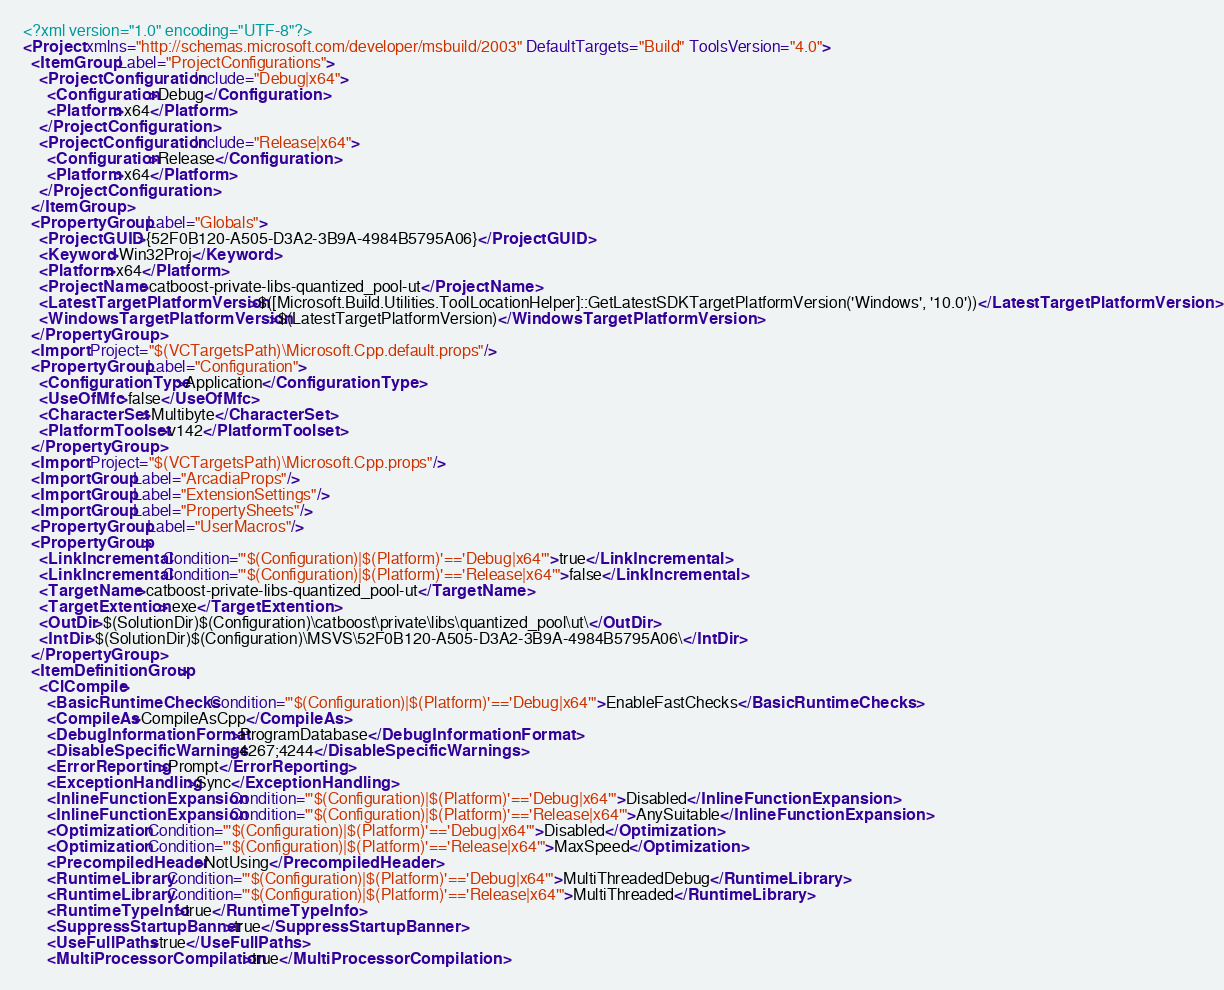Convert code to text. <code><loc_0><loc_0><loc_500><loc_500><_XML_><?xml version="1.0" encoding="UTF-8"?>
<Project xmlns="http://schemas.microsoft.com/developer/msbuild/2003" DefaultTargets="Build" ToolsVersion="4.0">
  <ItemGroup Label="ProjectConfigurations">
    <ProjectConfiguration Include="Debug|x64">
      <Configuration>Debug</Configuration>
      <Platform>x64</Platform>
    </ProjectConfiguration>
    <ProjectConfiguration Include="Release|x64">
      <Configuration>Release</Configuration>
      <Platform>x64</Platform>
    </ProjectConfiguration>
  </ItemGroup>
  <PropertyGroup Label="Globals">
    <ProjectGUID>{52F0B120-A505-D3A2-3B9A-4984B5795A06}</ProjectGUID>
    <Keyword>Win32Proj</Keyword>
    <Platform>x64</Platform>
    <ProjectName>catboost-private-libs-quantized_pool-ut</ProjectName>
    <LatestTargetPlatformVersion>$([Microsoft.Build.Utilities.ToolLocationHelper]::GetLatestSDKTargetPlatformVersion('Windows', '10.0'))</LatestTargetPlatformVersion>
    <WindowsTargetPlatformVersion>$(LatestTargetPlatformVersion)</WindowsTargetPlatformVersion>
  </PropertyGroup>
  <Import Project="$(VCTargetsPath)\Microsoft.Cpp.default.props"/>
  <PropertyGroup Label="Configuration">
    <ConfigurationType>Application</ConfigurationType>
    <UseOfMfc>false</UseOfMfc>
    <CharacterSet>Multibyte</CharacterSet>
    <PlatformToolset>v142</PlatformToolset>
  </PropertyGroup>
  <Import Project="$(VCTargetsPath)\Microsoft.Cpp.props"/>
  <ImportGroup Label="ArcadiaProps"/>
  <ImportGroup Label="ExtensionSettings"/>
  <ImportGroup Label="PropertySheets"/>
  <PropertyGroup Label="UserMacros"/>
  <PropertyGroup>
    <LinkIncremental Condition="'$(Configuration)|$(Platform)'=='Debug|x64'">true</LinkIncremental>
    <LinkIncremental Condition="'$(Configuration)|$(Platform)'=='Release|x64'">false</LinkIncremental>
    <TargetName>catboost-private-libs-quantized_pool-ut</TargetName>
    <TargetExtention>.exe</TargetExtention>
    <OutDir>$(SolutionDir)$(Configuration)\catboost\private\libs\quantized_pool\ut\</OutDir>
    <IntDir>$(SolutionDir)$(Configuration)\MSVS\52F0B120-A505-D3A2-3B9A-4984B5795A06\</IntDir>
  </PropertyGroup>
  <ItemDefinitionGroup>
    <ClCompile>
      <BasicRuntimeChecks Condition="'$(Configuration)|$(Platform)'=='Debug|x64'">EnableFastChecks</BasicRuntimeChecks>
      <CompileAs>CompileAsCpp</CompileAs>
      <DebugInformationFormat>ProgramDatabase</DebugInformationFormat>
      <DisableSpecificWarnings>4267;4244</DisableSpecificWarnings>
      <ErrorReporting>Prompt</ErrorReporting>
      <ExceptionHandling>Sync</ExceptionHandling>
      <InlineFunctionExpansion Condition="'$(Configuration)|$(Platform)'=='Debug|x64'">Disabled</InlineFunctionExpansion>
      <InlineFunctionExpansion Condition="'$(Configuration)|$(Platform)'=='Release|x64'">AnySuitable</InlineFunctionExpansion>
      <Optimization Condition="'$(Configuration)|$(Platform)'=='Debug|x64'">Disabled</Optimization>
      <Optimization Condition="'$(Configuration)|$(Platform)'=='Release|x64'">MaxSpeed</Optimization>
      <PrecompiledHeader>NotUsing</PrecompiledHeader>
      <RuntimeLibrary Condition="'$(Configuration)|$(Platform)'=='Debug|x64'">MultiThreadedDebug</RuntimeLibrary>
      <RuntimeLibrary Condition="'$(Configuration)|$(Platform)'=='Release|x64'">MultiThreaded</RuntimeLibrary>
      <RuntimeTypeInfo>true</RuntimeTypeInfo>
      <SuppressStartupBanner>true</SuppressStartupBanner>
      <UseFullPaths>true</UseFullPaths>
      <MultiProcessorCompilation>true</MultiProcessorCompilation></code> 